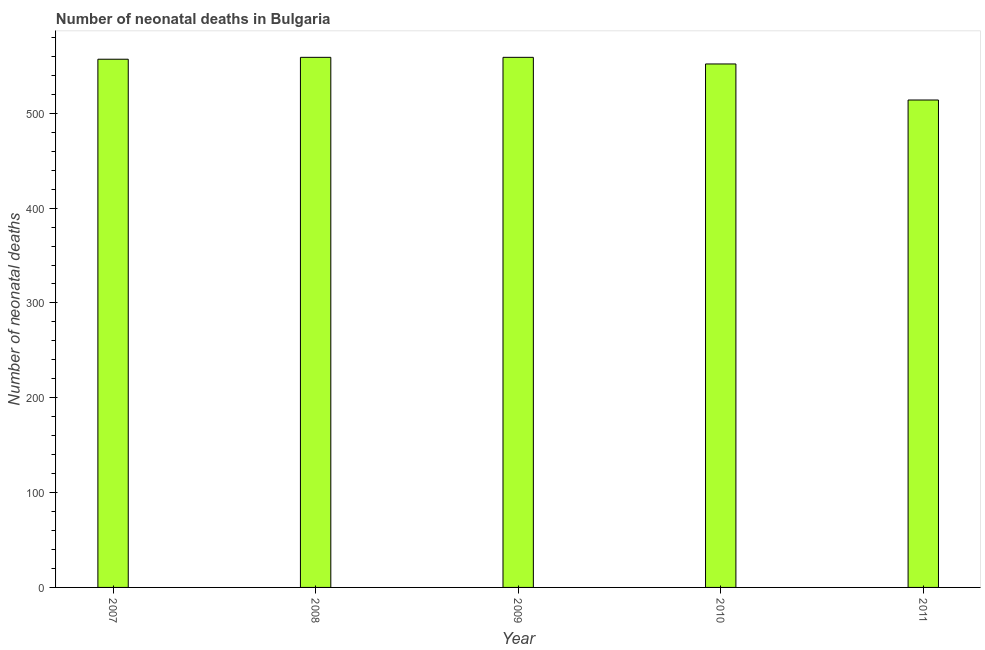Does the graph contain any zero values?
Keep it short and to the point. No. Does the graph contain grids?
Your answer should be very brief. No. What is the title of the graph?
Ensure brevity in your answer.  Number of neonatal deaths in Bulgaria. What is the label or title of the X-axis?
Keep it short and to the point. Year. What is the label or title of the Y-axis?
Your response must be concise. Number of neonatal deaths. What is the number of neonatal deaths in 2010?
Make the answer very short. 552. Across all years, what is the maximum number of neonatal deaths?
Offer a very short reply. 559. Across all years, what is the minimum number of neonatal deaths?
Provide a succinct answer. 514. What is the sum of the number of neonatal deaths?
Your answer should be very brief. 2741. What is the average number of neonatal deaths per year?
Offer a very short reply. 548. What is the median number of neonatal deaths?
Keep it short and to the point. 557. In how many years, is the number of neonatal deaths greater than 120 ?
Provide a short and direct response. 5. Do a majority of the years between 2008 and 2011 (inclusive) have number of neonatal deaths greater than 60 ?
Keep it short and to the point. Yes. What is the ratio of the number of neonatal deaths in 2009 to that in 2011?
Give a very brief answer. 1.09. Is the difference between the number of neonatal deaths in 2009 and 2011 greater than the difference between any two years?
Offer a terse response. Yes. How many years are there in the graph?
Your response must be concise. 5. What is the difference between two consecutive major ticks on the Y-axis?
Your response must be concise. 100. What is the Number of neonatal deaths in 2007?
Keep it short and to the point. 557. What is the Number of neonatal deaths in 2008?
Your response must be concise. 559. What is the Number of neonatal deaths in 2009?
Your answer should be compact. 559. What is the Number of neonatal deaths of 2010?
Your response must be concise. 552. What is the Number of neonatal deaths in 2011?
Your response must be concise. 514. What is the difference between the Number of neonatal deaths in 2007 and 2008?
Give a very brief answer. -2. What is the difference between the Number of neonatal deaths in 2007 and 2010?
Your answer should be compact. 5. What is the difference between the Number of neonatal deaths in 2008 and 2009?
Your response must be concise. 0. What is the difference between the Number of neonatal deaths in 2008 and 2010?
Give a very brief answer. 7. What is the ratio of the Number of neonatal deaths in 2007 to that in 2010?
Your answer should be very brief. 1.01. What is the ratio of the Number of neonatal deaths in 2007 to that in 2011?
Provide a succinct answer. 1.08. What is the ratio of the Number of neonatal deaths in 2008 to that in 2009?
Provide a succinct answer. 1. What is the ratio of the Number of neonatal deaths in 2008 to that in 2010?
Offer a terse response. 1.01. What is the ratio of the Number of neonatal deaths in 2008 to that in 2011?
Your answer should be compact. 1.09. What is the ratio of the Number of neonatal deaths in 2009 to that in 2011?
Offer a terse response. 1.09. What is the ratio of the Number of neonatal deaths in 2010 to that in 2011?
Make the answer very short. 1.07. 